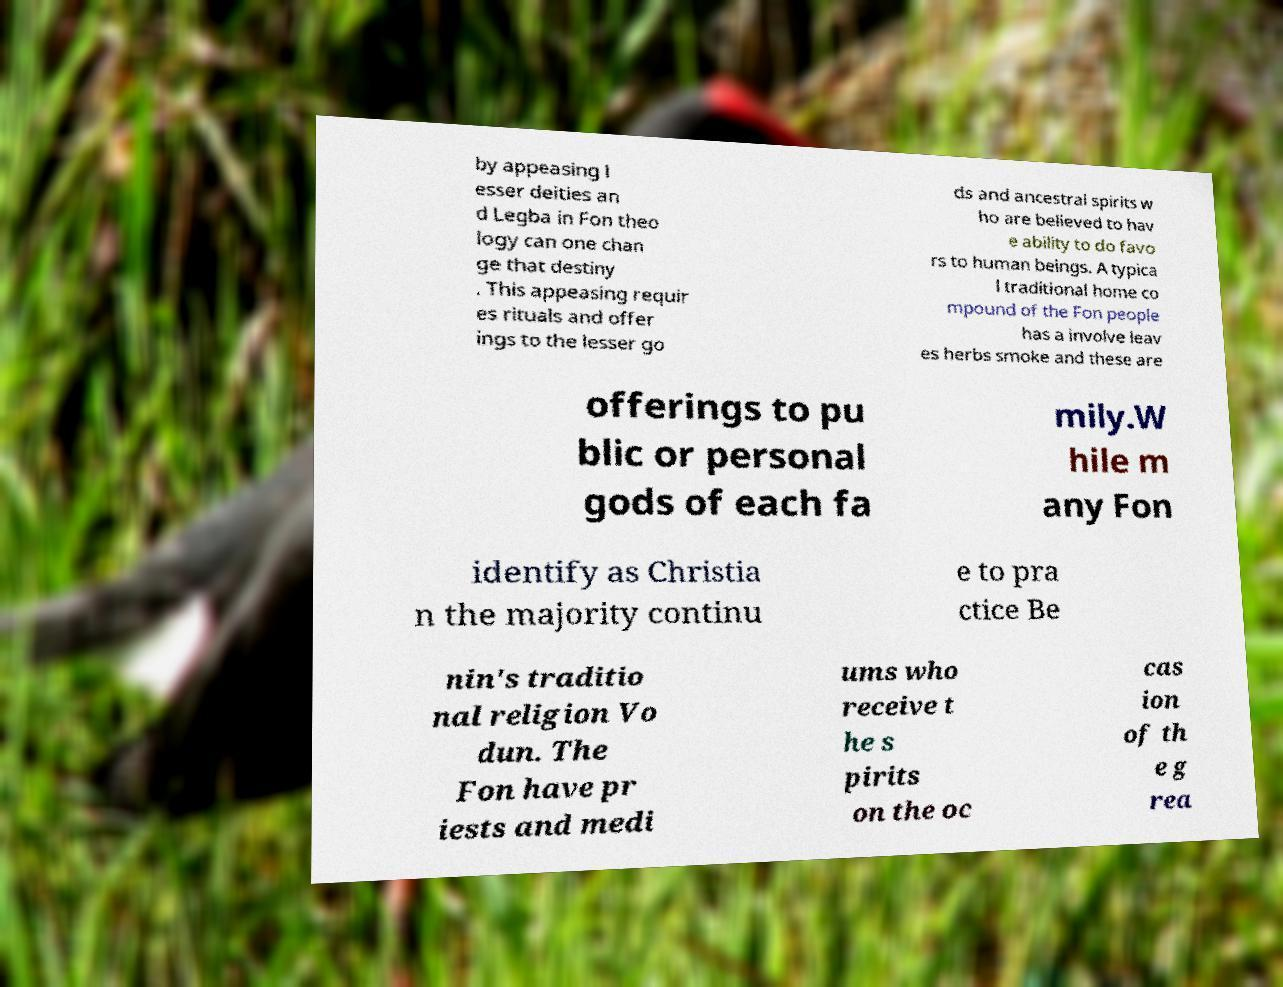Can you accurately transcribe the text from the provided image for me? by appeasing l esser deities an d Legba in Fon theo logy can one chan ge that destiny . This appeasing requir es rituals and offer ings to the lesser go ds and ancestral spirits w ho are believed to hav e ability to do favo rs to human beings. A typica l traditional home co mpound of the Fon people has a involve leav es herbs smoke and these are offerings to pu blic or personal gods of each fa mily.W hile m any Fon identify as Christia n the majority continu e to pra ctice Be nin's traditio nal religion Vo dun. The Fon have pr iests and medi ums who receive t he s pirits on the oc cas ion of th e g rea 